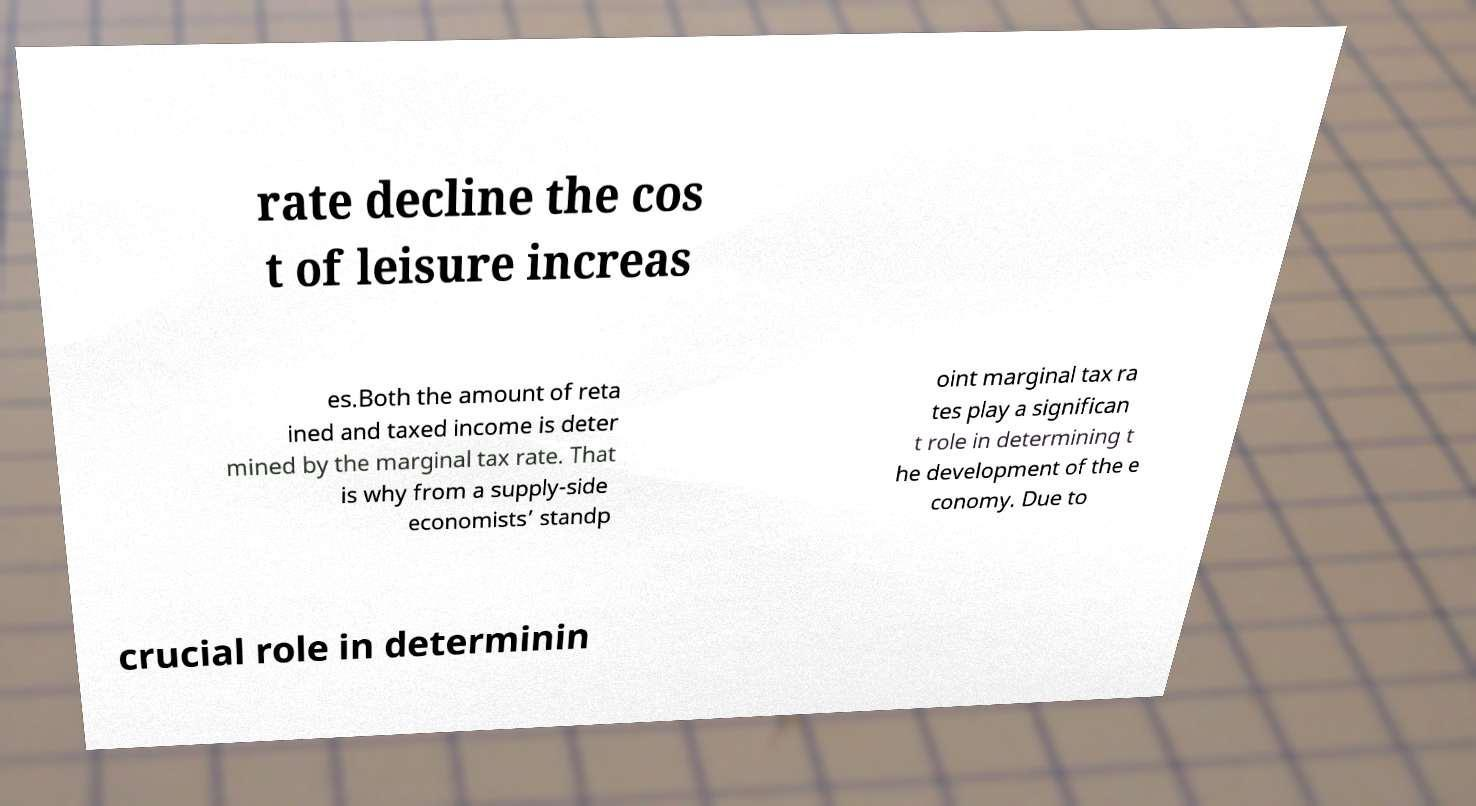Could you assist in decoding the text presented in this image and type it out clearly? rate decline the cos t of leisure increas es.Both the amount of reta ined and taxed income is deter mined by the marginal tax rate. That is why from a supply-side economists’ standp oint marginal tax ra tes play a significan t role in determining t he development of the e conomy. Due to crucial role in determinin 